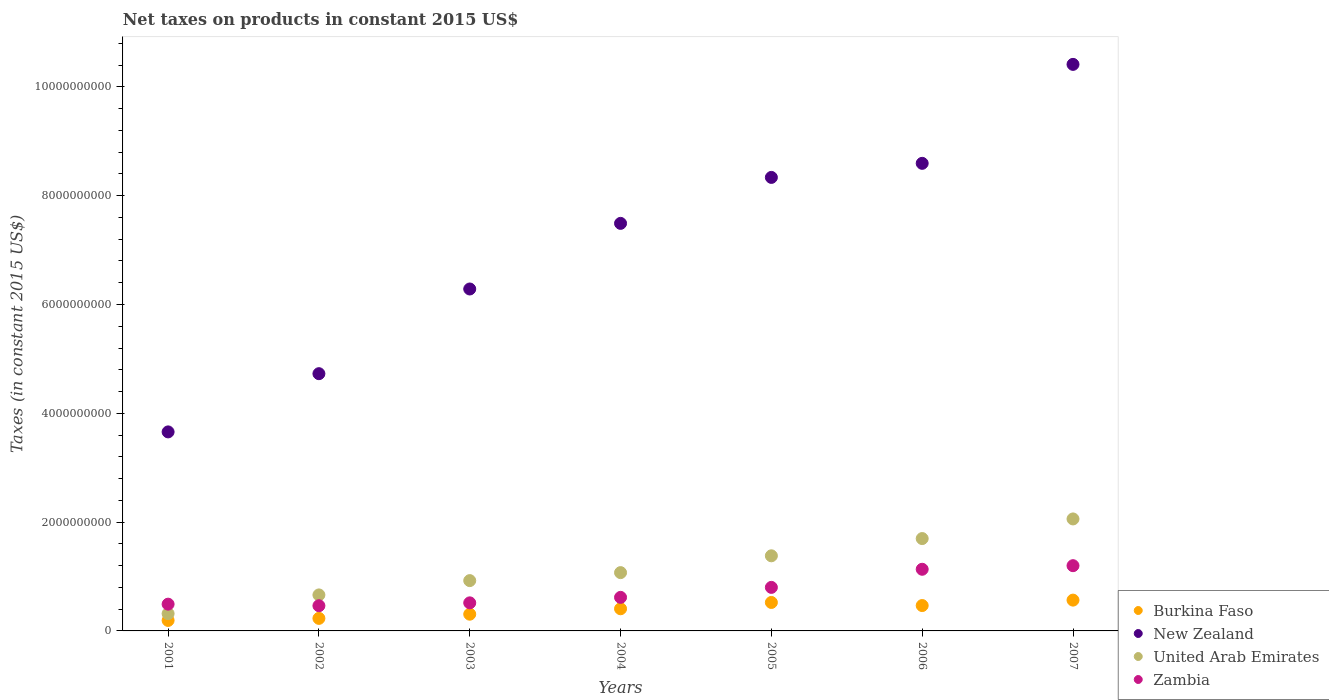What is the net taxes on products in New Zealand in 2002?
Keep it short and to the point. 4.73e+09. Across all years, what is the maximum net taxes on products in United Arab Emirates?
Provide a short and direct response. 2.06e+09. Across all years, what is the minimum net taxes on products in Zambia?
Your answer should be compact. 4.63e+08. What is the total net taxes on products in Burkina Faso in the graph?
Offer a very short reply. 2.69e+09. What is the difference between the net taxes on products in New Zealand in 2002 and that in 2006?
Give a very brief answer. -3.87e+09. What is the difference between the net taxes on products in New Zealand in 2006 and the net taxes on products in United Arab Emirates in 2004?
Provide a succinct answer. 7.52e+09. What is the average net taxes on products in United Arab Emirates per year?
Your answer should be compact. 1.16e+09. In the year 2005, what is the difference between the net taxes on products in Burkina Faso and net taxes on products in United Arab Emirates?
Offer a terse response. -8.57e+08. In how many years, is the net taxes on products in Zambia greater than 8800000000 US$?
Provide a short and direct response. 0. What is the ratio of the net taxes on products in Burkina Faso in 2006 to that in 2007?
Ensure brevity in your answer.  0.82. Is the net taxes on products in Zambia in 2005 less than that in 2006?
Your response must be concise. Yes. What is the difference between the highest and the second highest net taxes on products in United Arab Emirates?
Provide a succinct answer. 3.61e+08. What is the difference between the highest and the lowest net taxes on products in New Zealand?
Provide a succinct answer. 6.76e+09. In how many years, is the net taxes on products in Burkina Faso greater than the average net taxes on products in Burkina Faso taken over all years?
Ensure brevity in your answer.  4. Does the net taxes on products in Burkina Faso monotonically increase over the years?
Ensure brevity in your answer.  No. Is the net taxes on products in Burkina Faso strictly greater than the net taxes on products in Zambia over the years?
Offer a terse response. No. Is the net taxes on products in United Arab Emirates strictly less than the net taxes on products in Zambia over the years?
Give a very brief answer. No. How many years are there in the graph?
Keep it short and to the point. 7. Does the graph contain any zero values?
Provide a succinct answer. No. Does the graph contain grids?
Provide a short and direct response. No. How many legend labels are there?
Offer a very short reply. 4. What is the title of the graph?
Your answer should be compact. Net taxes on products in constant 2015 US$. What is the label or title of the Y-axis?
Keep it short and to the point. Taxes (in constant 2015 US$). What is the Taxes (in constant 2015 US$) in Burkina Faso in 2001?
Your response must be concise. 1.93e+08. What is the Taxes (in constant 2015 US$) of New Zealand in 2001?
Your answer should be very brief. 3.66e+09. What is the Taxes (in constant 2015 US$) in United Arab Emirates in 2001?
Provide a succinct answer. 3.18e+08. What is the Taxes (in constant 2015 US$) of Zambia in 2001?
Offer a terse response. 4.92e+08. What is the Taxes (in constant 2015 US$) in Burkina Faso in 2002?
Offer a very short reply. 2.31e+08. What is the Taxes (in constant 2015 US$) in New Zealand in 2002?
Provide a short and direct response. 4.73e+09. What is the Taxes (in constant 2015 US$) of United Arab Emirates in 2002?
Your answer should be compact. 6.62e+08. What is the Taxes (in constant 2015 US$) of Zambia in 2002?
Give a very brief answer. 4.63e+08. What is the Taxes (in constant 2015 US$) of Burkina Faso in 2003?
Your response must be concise. 3.07e+08. What is the Taxes (in constant 2015 US$) in New Zealand in 2003?
Offer a terse response. 6.28e+09. What is the Taxes (in constant 2015 US$) of United Arab Emirates in 2003?
Keep it short and to the point. 9.25e+08. What is the Taxes (in constant 2015 US$) of Zambia in 2003?
Your answer should be very brief. 5.16e+08. What is the Taxes (in constant 2015 US$) of Burkina Faso in 2004?
Keep it short and to the point. 4.07e+08. What is the Taxes (in constant 2015 US$) of New Zealand in 2004?
Offer a very short reply. 7.49e+09. What is the Taxes (in constant 2015 US$) in United Arab Emirates in 2004?
Provide a succinct answer. 1.07e+09. What is the Taxes (in constant 2015 US$) of Zambia in 2004?
Your response must be concise. 6.17e+08. What is the Taxes (in constant 2015 US$) of Burkina Faso in 2005?
Your answer should be compact. 5.23e+08. What is the Taxes (in constant 2015 US$) of New Zealand in 2005?
Keep it short and to the point. 8.34e+09. What is the Taxes (in constant 2015 US$) of United Arab Emirates in 2005?
Provide a short and direct response. 1.38e+09. What is the Taxes (in constant 2015 US$) of Zambia in 2005?
Ensure brevity in your answer.  8.00e+08. What is the Taxes (in constant 2015 US$) in Burkina Faso in 2006?
Your answer should be very brief. 4.66e+08. What is the Taxes (in constant 2015 US$) of New Zealand in 2006?
Keep it short and to the point. 8.59e+09. What is the Taxes (in constant 2015 US$) of United Arab Emirates in 2006?
Your answer should be compact. 1.70e+09. What is the Taxes (in constant 2015 US$) of Zambia in 2006?
Provide a short and direct response. 1.13e+09. What is the Taxes (in constant 2015 US$) of Burkina Faso in 2007?
Offer a terse response. 5.66e+08. What is the Taxes (in constant 2015 US$) in New Zealand in 2007?
Keep it short and to the point. 1.04e+1. What is the Taxes (in constant 2015 US$) of United Arab Emirates in 2007?
Offer a very short reply. 2.06e+09. What is the Taxes (in constant 2015 US$) in Zambia in 2007?
Your response must be concise. 1.20e+09. Across all years, what is the maximum Taxes (in constant 2015 US$) of Burkina Faso?
Offer a terse response. 5.66e+08. Across all years, what is the maximum Taxes (in constant 2015 US$) in New Zealand?
Give a very brief answer. 1.04e+1. Across all years, what is the maximum Taxes (in constant 2015 US$) in United Arab Emirates?
Your answer should be compact. 2.06e+09. Across all years, what is the maximum Taxes (in constant 2015 US$) in Zambia?
Give a very brief answer. 1.20e+09. Across all years, what is the minimum Taxes (in constant 2015 US$) in Burkina Faso?
Offer a very short reply. 1.93e+08. Across all years, what is the minimum Taxes (in constant 2015 US$) of New Zealand?
Offer a very short reply. 3.66e+09. Across all years, what is the minimum Taxes (in constant 2015 US$) of United Arab Emirates?
Ensure brevity in your answer.  3.18e+08. Across all years, what is the minimum Taxes (in constant 2015 US$) in Zambia?
Provide a succinct answer. 4.63e+08. What is the total Taxes (in constant 2015 US$) of Burkina Faso in the graph?
Ensure brevity in your answer.  2.69e+09. What is the total Taxes (in constant 2015 US$) of New Zealand in the graph?
Offer a terse response. 4.95e+1. What is the total Taxes (in constant 2015 US$) of United Arab Emirates in the graph?
Offer a very short reply. 8.11e+09. What is the total Taxes (in constant 2015 US$) of Zambia in the graph?
Make the answer very short. 5.22e+09. What is the difference between the Taxes (in constant 2015 US$) in Burkina Faso in 2001 and that in 2002?
Give a very brief answer. -3.78e+07. What is the difference between the Taxes (in constant 2015 US$) in New Zealand in 2001 and that in 2002?
Offer a very short reply. -1.07e+09. What is the difference between the Taxes (in constant 2015 US$) of United Arab Emirates in 2001 and that in 2002?
Your response must be concise. -3.44e+08. What is the difference between the Taxes (in constant 2015 US$) in Zambia in 2001 and that in 2002?
Your answer should be compact. 2.89e+07. What is the difference between the Taxes (in constant 2015 US$) of Burkina Faso in 2001 and that in 2003?
Your answer should be compact. -1.15e+08. What is the difference between the Taxes (in constant 2015 US$) in New Zealand in 2001 and that in 2003?
Your response must be concise. -2.63e+09. What is the difference between the Taxes (in constant 2015 US$) in United Arab Emirates in 2001 and that in 2003?
Make the answer very short. -6.07e+08. What is the difference between the Taxes (in constant 2015 US$) in Zambia in 2001 and that in 2003?
Give a very brief answer. -2.42e+07. What is the difference between the Taxes (in constant 2015 US$) in Burkina Faso in 2001 and that in 2004?
Make the answer very short. -2.14e+08. What is the difference between the Taxes (in constant 2015 US$) in New Zealand in 2001 and that in 2004?
Offer a terse response. -3.83e+09. What is the difference between the Taxes (in constant 2015 US$) in United Arab Emirates in 2001 and that in 2004?
Offer a very short reply. -7.54e+08. What is the difference between the Taxes (in constant 2015 US$) of Zambia in 2001 and that in 2004?
Make the answer very short. -1.25e+08. What is the difference between the Taxes (in constant 2015 US$) in Burkina Faso in 2001 and that in 2005?
Offer a terse response. -3.30e+08. What is the difference between the Taxes (in constant 2015 US$) of New Zealand in 2001 and that in 2005?
Provide a short and direct response. -4.68e+09. What is the difference between the Taxes (in constant 2015 US$) of United Arab Emirates in 2001 and that in 2005?
Keep it short and to the point. -1.06e+09. What is the difference between the Taxes (in constant 2015 US$) of Zambia in 2001 and that in 2005?
Provide a succinct answer. -3.08e+08. What is the difference between the Taxes (in constant 2015 US$) in Burkina Faso in 2001 and that in 2006?
Provide a short and direct response. -2.74e+08. What is the difference between the Taxes (in constant 2015 US$) in New Zealand in 2001 and that in 2006?
Your answer should be very brief. -4.94e+09. What is the difference between the Taxes (in constant 2015 US$) of United Arab Emirates in 2001 and that in 2006?
Ensure brevity in your answer.  -1.38e+09. What is the difference between the Taxes (in constant 2015 US$) in Zambia in 2001 and that in 2006?
Ensure brevity in your answer.  -6.41e+08. What is the difference between the Taxes (in constant 2015 US$) of Burkina Faso in 2001 and that in 2007?
Your answer should be very brief. -3.73e+08. What is the difference between the Taxes (in constant 2015 US$) of New Zealand in 2001 and that in 2007?
Provide a short and direct response. -6.76e+09. What is the difference between the Taxes (in constant 2015 US$) in United Arab Emirates in 2001 and that in 2007?
Keep it short and to the point. -1.74e+09. What is the difference between the Taxes (in constant 2015 US$) in Zambia in 2001 and that in 2007?
Provide a short and direct response. -7.07e+08. What is the difference between the Taxes (in constant 2015 US$) of Burkina Faso in 2002 and that in 2003?
Give a very brief answer. -7.69e+07. What is the difference between the Taxes (in constant 2015 US$) of New Zealand in 2002 and that in 2003?
Your response must be concise. -1.56e+09. What is the difference between the Taxes (in constant 2015 US$) in United Arab Emirates in 2002 and that in 2003?
Give a very brief answer. -2.63e+08. What is the difference between the Taxes (in constant 2015 US$) in Zambia in 2002 and that in 2003?
Offer a terse response. -5.31e+07. What is the difference between the Taxes (in constant 2015 US$) of Burkina Faso in 2002 and that in 2004?
Keep it short and to the point. -1.77e+08. What is the difference between the Taxes (in constant 2015 US$) of New Zealand in 2002 and that in 2004?
Provide a short and direct response. -2.76e+09. What is the difference between the Taxes (in constant 2015 US$) of United Arab Emirates in 2002 and that in 2004?
Offer a very short reply. -4.10e+08. What is the difference between the Taxes (in constant 2015 US$) of Zambia in 2002 and that in 2004?
Your response must be concise. -1.54e+08. What is the difference between the Taxes (in constant 2015 US$) in Burkina Faso in 2002 and that in 2005?
Give a very brief answer. -2.93e+08. What is the difference between the Taxes (in constant 2015 US$) of New Zealand in 2002 and that in 2005?
Your answer should be compact. -3.61e+09. What is the difference between the Taxes (in constant 2015 US$) of United Arab Emirates in 2002 and that in 2005?
Your response must be concise. -7.19e+08. What is the difference between the Taxes (in constant 2015 US$) of Zambia in 2002 and that in 2005?
Keep it short and to the point. -3.37e+08. What is the difference between the Taxes (in constant 2015 US$) in Burkina Faso in 2002 and that in 2006?
Keep it short and to the point. -2.36e+08. What is the difference between the Taxes (in constant 2015 US$) in New Zealand in 2002 and that in 2006?
Your answer should be very brief. -3.87e+09. What is the difference between the Taxes (in constant 2015 US$) in United Arab Emirates in 2002 and that in 2006?
Keep it short and to the point. -1.04e+09. What is the difference between the Taxes (in constant 2015 US$) in Zambia in 2002 and that in 2006?
Ensure brevity in your answer.  -6.70e+08. What is the difference between the Taxes (in constant 2015 US$) of Burkina Faso in 2002 and that in 2007?
Your response must be concise. -3.36e+08. What is the difference between the Taxes (in constant 2015 US$) in New Zealand in 2002 and that in 2007?
Offer a very short reply. -5.68e+09. What is the difference between the Taxes (in constant 2015 US$) of United Arab Emirates in 2002 and that in 2007?
Make the answer very short. -1.40e+09. What is the difference between the Taxes (in constant 2015 US$) in Zambia in 2002 and that in 2007?
Provide a succinct answer. -7.36e+08. What is the difference between the Taxes (in constant 2015 US$) of Burkina Faso in 2003 and that in 2004?
Offer a terse response. -9.97e+07. What is the difference between the Taxes (in constant 2015 US$) of New Zealand in 2003 and that in 2004?
Give a very brief answer. -1.21e+09. What is the difference between the Taxes (in constant 2015 US$) in United Arab Emirates in 2003 and that in 2004?
Your response must be concise. -1.47e+08. What is the difference between the Taxes (in constant 2015 US$) in Zambia in 2003 and that in 2004?
Keep it short and to the point. -1.01e+08. What is the difference between the Taxes (in constant 2015 US$) in Burkina Faso in 2003 and that in 2005?
Make the answer very short. -2.16e+08. What is the difference between the Taxes (in constant 2015 US$) in New Zealand in 2003 and that in 2005?
Offer a terse response. -2.05e+09. What is the difference between the Taxes (in constant 2015 US$) of United Arab Emirates in 2003 and that in 2005?
Your response must be concise. -4.56e+08. What is the difference between the Taxes (in constant 2015 US$) in Zambia in 2003 and that in 2005?
Your answer should be very brief. -2.84e+08. What is the difference between the Taxes (in constant 2015 US$) of Burkina Faso in 2003 and that in 2006?
Offer a very short reply. -1.59e+08. What is the difference between the Taxes (in constant 2015 US$) in New Zealand in 2003 and that in 2006?
Give a very brief answer. -2.31e+09. What is the difference between the Taxes (in constant 2015 US$) in United Arab Emirates in 2003 and that in 2006?
Offer a terse response. -7.73e+08. What is the difference between the Taxes (in constant 2015 US$) in Zambia in 2003 and that in 2006?
Provide a short and direct response. -6.17e+08. What is the difference between the Taxes (in constant 2015 US$) of Burkina Faso in 2003 and that in 2007?
Offer a very short reply. -2.59e+08. What is the difference between the Taxes (in constant 2015 US$) of New Zealand in 2003 and that in 2007?
Make the answer very short. -4.13e+09. What is the difference between the Taxes (in constant 2015 US$) of United Arab Emirates in 2003 and that in 2007?
Offer a very short reply. -1.13e+09. What is the difference between the Taxes (in constant 2015 US$) of Zambia in 2003 and that in 2007?
Make the answer very short. -6.83e+08. What is the difference between the Taxes (in constant 2015 US$) of Burkina Faso in 2004 and that in 2005?
Provide a short and direct response. -1.16e+08. What is the difference between the Taxes (in constant 2015 US$) in New Zealand in 2004 and that in 2005?
Offer a very short reply. -8.45e+08. What is the difference between the Taxes (in constant 2015 US$) of United Arab Emirates in 2004 and that in 2005?
Make the answer very short. -3.09e+08. What is the difference between the Taxes (in constant 2015 US$) of Zambia in 2004 and that in 2005?
Provide a short and direct response. -1.84e+08. What is the difference between the Taxes (in constant 2015 US$) of Burkina Faso in 2004 and that in 2006?
Offer a very short reply. -5.92e+07. What is the difference between the Taxes (in constant 2015 US$) of New Zealand in 2004 and that in 2006?
Your answer should be compact. -1.10e+09. What is the difference between the Taxes (in constant 2015 US$) in United Arab Emirates in 2004 and that in 2006?
Your answer should be compact. -6.26e+08. What is the difference between the Taxes (in constant 2015 US$) of Zambia in 2004 and that in 2006?
Offer a very short reply. -5.16e+08. What is the difference between the Taxes (in constant 2015 US$) in Burkina Faso in 2004 and that in 2007?
Offer a terse response. -1.59e+08. What is the difference between the Taxes (in constant 2015 US$) of New Zealand in 2004 and that in 2007?
Your response must be concise. -2.92e+09. What is the difference between the Taxes (in constant 2015 US$) in United Arab Emirates in 2004 and that in 2007?
Provide a short and direct response. -9.87e+08. What is the difference between the Taxes (in constant 2015 US$) of Zambia in 2004 and that in 2007?
Give a very brief answer. -5.82e+08. What is the difference between the Taxes (in constant 2015 US$) in Burkina Faso in 2005 and that in 2006?
Your answer should be compact. 5.68e+07. What is the difference between the Taxes (in constant 2015 US$) in New Zealand in 2005 and that in 2006?
Your answer should be very brief. -2.59e+08. What is the difference between the Taxes (in constant 2015 US$) of United Arab Emirates in 2005 and that in 2006?
Keep it short and to the point. -3.17e+08. What is the difference between the Taxes (in constant 2015 US$) in Zambia in 2005 and that in 2006?
Keep it short and to the point. -3.33e+08. What is the difference between the Taxes (in constant 2015 US$) of Burkina Faso in 2005 and that in 2007?
Provide a succinct answer. -4.30e+07. What is the difference between the Taxes (in constant 2015 US$) of New Zealand in 2005 and that in 2007?
Ensure brevity in your answer.  -2.08e+09. What is the difference between the Taxes (in constant 2015 US$) in United Arab Emirates in 2005 and that in 2007?
Make the answer very short. -6.78e+08. What is the difference between the Taxes (in constant 2015 US$) of Zambia in 2005 and that in 2007?
Make the answer very short. -3.99e+08. What is the difference between the Taxes (in constant 2015 US$) of Burkina Faso in 2006 and that in 2007?
Offer a very short reply. -9.98e+07. What is the difference between the Taxes (in constant 2015 US$) in New Zealand in 2006 and that in 2007?
Offer a very short reply. -1.82e+09. What is the difference between the Taxes (in constant 2015 US$) of United Arab Emirates in 2006 and that in 2007?
Give a very brief answer. -3.61e+08. What is the difference between the Taxes (in constant 2015 US$) in Zambia in 2006 and that in 2007?
Your answer should be compact. -6.60e+07. What is the difference between the Taxes (in constant 2015 US$) in Burkina Faso in 2001 and the Taxes (in constant 2015 US$) in New Zealand in 2002?
Offer a very short reply. -4.54e+09. What is the difference between the Taxes (in constant 2015 US$) of Burkina Faso in 2001 and the Taxes (in constant 2015 US$) of United Arab Emirates in 2002?
Provide a succinct answer. -4.69e+08. What is the difference between the Taxes (in constant 2015 US$) in Burkina Faso in 2001 and the Taxes (in constant 2015 US$) in Zambia in 2002?
Keep it short and to the point. -2.70e+08. What is the difference between the Taxes (in constant 2015 US$) in New Zealand in 2001 and the Taxes (in constant 2015 US$) in United Arab Emirates in 2002?
Your answer should be very brief. 3.00e+09. What is the difference between the Taxes (in constant 2015 US$) in New Zealand in 2001 and the Taxes (in constant 2015 US$) in Zambia in 2002?
Offer a very short reply. 3.20e+09. What is the difference between the Taxes (in constant 2015 US$) in United Arab Emirates in 2001 and the Taxes (in constant 2015 US$) in Zambia in 2002?
Offer a very short reply. -1.45e+08. What is the difference between the Taxes (in constant 2015 US$) in Burkina Faso in 2001 and the Taxes (in constant 2015 US$) in New Zealand in 2003?
Make the answer very short. -6.09e+09. What is the difference between the Taxes (in constant 2015 US$) of Burkina Faso in 2001 and the Taxes (in constant 2015 US$) of United Arab Emirates in 2003?
Make the answer very short. -7.32e+08. What is the difference between the Taxes (in constant 2015 US$) in Burkina Faso in 2001 and the Taxes (in constant 2015 US$) in Zambia in 2003?
Make the answer very short. -3.23e+08. What is the difference between the Taxes (in constant 2015 US$) of New Zealand in 2001 and the Taxes (in constant 2015 US$) of United Arab Emirates in 2003?
Your response must be concise. 2.73e+09. What is the difference between the Taxes (in constant 2015 US$) of New Zealand in 2001 and the Taxes (in constant 2015 US$) of Zambia in 2003?
Ensure brevity in your answer.  3.14e+09. What is the difference between the Taxes (in constant 2015 US$) in United Arab Emirates in 2001 and the Taxes (in constant 2015 US$) in Zambia in 2003?
Keep it short and to the point. -1.98e+08. What is the difference between the Taxes (in constant 2015 US$) of Burkina Faso in 2001 and the Taxes (in constant 2015 US$) of New Zealand in 2004?
Make the answer very short. -7.30e+09. What is the difference between the Taxes (in constant 2015 US$) of Burkina Faso in 2001 and the Taxes (in constant 2015 US$) of United Arab Emirates in 2004?
Offer a very short reply. -8.79e+08. What is the difference between the Taxes (in constant 2015 US$) of Burkina Faso in 2001 and the Taxes (in constant 2015 US$) of Zambia in 2004?
Make the answer very short. -4.24e+08. What is the difference between the Taxes (in constant 2015 US$) of New Zealand in 2001 and the Taxes (in constant 2015 US$) of United Arab Emirates in 2004?
Your answer should be compact. 2.59e+09. What is the difference between the Taxes (in constant 2015 US$) of New Zealand in 2001 and the Taxes (in constant 2015 US$) of Zambia in 2004?
Ensure brevity in your answer.  3.04e+09. What is the difference between the Taxes (in constant 2015 US$) of United Arab Emirates in 2001 and the Taxes (in constant 2015 US$) of Zambia in 2004?
Your answer should be very brief. -2.99e+08. What is the difference between the Taxes (in constant 2015 US$) of Burkina Faso in 2001 and the Taxes (in constant 2015 US$) of New Zealand in 2005?
Make the answer very short. -8.14e+09. What is the difference between the Taxes (in constant 2015 US$) in Burkina Faso in 2001 and the Taxes (in constant 2015 US$) in United Arab Emirates in 2005?
Your answer should be compact. -1.19e+09. What is the difference between the Taxes (in constant 2015 US$) in Burkina Faso in 2001 and the Taxes (in constant 2015 US$) in Zambia in 2005?
Provide a succinct answer. -6.07e+08. What is the difference between the Taxes (in constant 2015 US$) in New Zealand in 2001 and the Taxes (in constant 2015 US$) in United Arab Emirates in 2005?
Keep it short and to the point. 2.28e+09. What is the difference between the Taxes (in constant 2015 US$) in New Zealand in 2001 and the Taxes (in constant 2015 US$) in Zambia in 2005?
Provide a succinct answer. 2.86e+09. What is the difference between the Taxes (in constant 2015 US$) of United Arab Emirates in 2001 and the Taxes (in constant 2015 US$) of Zambia in 2005?
Give a very brief answer. -4.82e+08. What is the difference between the Taxes (in constant 2015 US$) of Burkina Faso in 2001 and the Taxes (in constant 2015 US$) of New Zealand in 2006?
Give a very brief answer. -8.40e+09. What is the difference between the Taxes (in constant 2015 US$) in Burkina Faso in 2001 and the Taxes (in constant 2015 US$) in United Arab Emirates in 2006?
Ensure brevity in your answer.  -1.50e+09. What is the difference between the Taxes (in constant 2015 US$) in Burkina Faso in 2001 and the Taxes (in constant 2015 US$) in Zambia in 2006?
Provide a short and direct response. -9.40e+08. What is the difference between the Taxes (in constant 2015 US$) in New Zealand in 2001 and the Taxes (in constant 2015 US$) in United Arab Emirates in 2006?
Ensure brevity in your answer.  1.96e+09. What is the difference between the Taxes (in constant 2015 US$) in New Zealand in 2001 and the Taxes (in constant 2015 US$) in Zambia in 2006?
Provide a succinct answer. 2.52e+09. What is the difference between the Taxes (in constant 2015 US$) of United Arab Emirates in 2001 and the Taxes (in constant 2015 US$) of Zambia in 2006?
Offer a terse response. -8.15e+08. What is the difference between the Taxes (in constant 2015 US$) of Burkina Faso in 2001 and the Taxes (in constant 2015 US$) of New Zealand in 2007?
Provide a succinct answer. -1.02e+1. What is the difference between the Taxes (in constant 2015 US$) of Burkina Faso in 2001 and the Taxes (in constant 2015 US$) of United Arab Emirates in 2007?
Ensure brevity in your answer.  -1.87e+09. What is the difference between the Taxes (in constant 2015 US$) in Burkina Faso in 2001 and the Taxes (in constant 2015 US$) in Zambia in 2007?
Ensure brevity in your answer.  -1.01e+09. What is the difference between the Taxes (in constant 2015 US$) in New Zealand in 2001 and the Taxes (in constant 2015 US$) in United Arab Emirates in 2007?
Make the answer very short. 1.60e+09. What is the difference between the Taxes (in constant 2015 US$) of New Zealand in 2001 and the Taxes (in constant 2015 US$) of Zambia in 2007?
Provide a short and direct response. 2.46e+09. What is the difference between the Taxes (in constant 2015 US$) in United Arab Emirates in 2001 and the Taxes (in constant 2015 US$) in Zambia in 2007?
Ensure brevity in your answer.  -8.81e+08. What is the difference between the Taxes (in constant 2015 US$) of Burkina Faso in 2002 and the Taxes (in constant 2015 US$) of New Zealand in 2003?
Provide a short and direct response. -6.05e+09. What is the difference between the Taxes (in constant 2015 US$) in Burkina Faso in 2002 and the Taxes (in constant 2015 US$) in United Arab Emirates in 2003?
Give a very brief answer. -6.94e+08. What is the difference between the Taxes (in constant 2015 US$) in Burkina Faso in 2002 and the Taxes (in constant 2015 US$) in Zambia in 2003?
Your answer should be very brief. -2.86e+08. What is the difference between the Taxes (in constant 2015 US$) in New Zealand in 2002 and the Taxes (in constant 2015 US$) in United Arab Emirates in 2003?
Offer a terse response. 3.80e+09. What is the difference between the Taxes (in constant 2015 US$) in New Zealand in 2002 and the Taxes (in constant 2015 US$) in Zambia in 2003?
Provide a short and direct response. 4.21e+09. What is the difference between the Taxes (in constant 2015 US$) in United Arab Emirates in 2002 and the Taxes (in constant 2015 US$) in Zambia in 2003?
Your answer should be compact. 1.46e+08. What is the difference between the Taxes (in constant 2015 US$) of Burkina Faso in 2002 and the Taxes (in constant 2015 US$) of New Zealand in 2004?
Make the answer very short. -7.26e+09. What is the difference between the Taxes (in constant 2015 US$) of Burkina Faso in 2002 and the Taxes (in constant 2015 US$) of United Arab Emirates in 2004?
Provide a short and direct response. -8.41e+08. What is the difference between the Taxes (in constant 2015 US$) in Burkina Faso in 2002 and the Taxes (in constant 2015 US$) in Zambia in 2004?
Your answer should be very brief. -3.86e+08. What is the difference between the Taxes (in constant 2015 US$) in New Zealand in 2002 and the Taxes (in constant 2015 US$) in United Arab Emirates in 2004?
Your answer should be compact. 3.66e+09. What is the difference between the Taxes (in constant 2015 US$) in New Zealand in 2002 and the Taxes (in constant 2015 US$) in Zambia in 2004?
Your answer should be compact. 4.11e+09. What is the difference between the Taxes (in constant 2015 US$) in United Arab Emirates in 2002 and the Taxes (in constant 2015 US$) in Zambia in 2004?
Offer a very short reply. 4.50e+07. What is the difference between the Taxes (in constant 2015 US$) of Burkina Faso in 2002 and the Taxes (in constant 2015 US$) of New Zealand in 2005?
Your answer should be compact. -8.11e+09. What is the difference between the Taxes (in constant 2015 US$) in Burkina Faso in 2002 and the Taxes (in constant 2015 US$) in United Arab Emirates in 2005?
Your response must be concise. -1.15e+09. What is the difference between the Taxes (in constant 2015 US$) of Burkina Faso in 2002 and the Taxes (in constant 2015 US$) of Zambia in 2005?
Offer a very short reply. -5.70e+08. What is the difference between the Taxes (in constant 2015 US$) in New Zealand in 2002 and the Taxes (in constant 2015 US$) in United Arab Emirates in 2005?
Provide a succinct answer. 3.35e+09. What is the difference between the Taxes (in constant 2015 US$) of New Zealand in 2002 and the Taxes (in constant 2015 US$) of Zambia in 2005?
Your response must be concise. 3.93e+09. What is the difference between the Taxes (in constant 2015 US$) of United Arab Emirates in 2002 and the Taxes (in constant 2015 US$) of Zambia in 2005?
Make the answer very short. -1.39e+08. What is the difference between the Taxes (in constant 2015 US$) in Burkina Faso in 2002 and the Taxes (in constant 2015 US$) in New Zealand in 2006?
Your response must be concise. -8.36e+09. What is the difference between the Taxes (in constant 2015 US$) of Burkina Faso in 2002 and the Taxes (in constant 2015 US$) of United Arab Emirates in 2006?
Your response must be concise. -1.47e+09. What is the difference between the Taxes (in constant 2015 US$) of Burkina Faso in 2002 and the Taxes (in constant 2015 US$) of Zambia in 2006?
Offer a very short reply. -9.03e+08. What is the difference between the Taxes (in constant 2015 US$) in New Zealand in 2002 and the Taxes (in constant 2015 US$) in United Arab Emirates in 2006?
Give a very brief answer. 3.03e+09. What is the difference between the Taxes (in constant 2015 US$) of New Zealand in 2002 and the Taxes (in constant 2015 US$) of Zambia in 2006?
Keep it short and to the point. 3.59e+09. What is the difference between the Taxes (in constant 2015 US$) of United Arab Emirates in 2002 and the Taxes (in constant 2015 US$) of Zambia in 2006?
Your response must be concise. -4.71e+08. What is the difference between the Taxes (in constant 2015 US$) in Burkina Faso in 2002 and the Taxes (in constant 2015 US$) in New Zealand in 2007?
Make the answer very short. -1.02e+1. What is the difference between the Taxes (in constant 2015 US$) in Burkina Faso in 2002 and the Taxes (in constant 2015 US$) in United Arab Emirates in 2007?
Provide a succinct answer. -1.83e+09. What is the difference between the Taxes (in constant 2015 US$) in Burkina Faso in 2002 and the Taxes (in constant 2015 US$) in Zambia in 2007?
Ensure brevity in your answer.  -9.69e+08. What is the difference between the Taxes (in constant 2015 US$) in New Zealand in 2002 and the Taxes (in constant 2015 US$) in United Arab Emirates in 2007?
Your answer should be very brief. 2.67e+09. What is the difference between the Taxes (in constant 2015 US$) in New Zealand in 2002 and the Taxes (in constant 2015 US$) in Zambia in 2007?
Your response must be concise. 3.53e+09. What is the difference between the Taxes (in constant 2015 US$) of United Arab Emirates in 2002 and the Taxes (in constant 2015 US$) of Zambia in 2007?
Offer a terse response. -5.37e+08. What is the difference between the Taxes (in constant 2015 US$) in Burkina Faso in 2003 and the Taxes (in constant 2015 US$) in New Zealand in 2004?
Your answer should be compact. -7.18e+09. What is the difference between the Taxes (in constant 2015 US$) of Burkina Faso in 2003 and the Taxes (in constant 2015 US$) of United Arab Emirates in 2004?
Offer a terse response. -7.64e+08. What is the difference between the Taxes (in constant 2015 US$) of Burkina Faso in 2003 and the Taxes (in constant 2015 US$) of Zambia in 2004?
Make the answer very short. -3.09e+08. What is the difference between the Taxes (in constant 2015 US$) in New Zealand in 2003 and the Taxes (in constant 2015 US$) in United Arab Emirates in 2004?
Make the answer very short. 5.21e+09. What is the difference between the Taxes (in constant 2015 US$) in New Zealand in 2003 and the Taxes (in constant 2015 US$) in Zambia in 2004?
Keep it short and to the point. 5.67e+09. What is the difference between the Taxes (in constant 2015 US$) in United Arab Emirates in 2003 and the Taxes (in constant 2015 US$) in Zambia in 2004?
Give a very brief answer. 3.08e+08. What is the difference between the Taxes (in constant 2015 US$) of Burkina Faso in 2003 and the Taxes (in constant 2015 US$) of New Zealand in 2005?
Your answer should be very brief. -8.03e+09. What is the difference between the Taxes (in constant 2015 US$) in Burkina Faso in 2003 and the Taxes (in constant 2015 US$) in United Arab Emirates in 2005?
Your answer should be very brief. -1.07e+09. What is the difference between the Taxes (in constant 2015 US$) in Burkina Faso in 2003 and the Taxes (in constant 2015 US$) in Zambia in 2005?
Provide a short and direct response. -4.93e+08. What is the difference between the Taxes (in constant 2015 US$) of New Zealand in 2003 and the Taxes (in constant 2015 US$) of United Arab Emirates in 2005?
Your response must be concise. 4.90e+09. What is the difference between the Taxes (in constant 2015 US$) of New Zealand in 2003 and the Taxes (in constant 2015 US$) of Zambia in 2005?
Your answer should be compact. 5.48e+09. What is the difference between the Taxes (in constant 2015 US$) of United Arab Emirates in 2003 and the Taxes (in constant 2015 US$) of Zambia in 2005?
Keep it short and to the point. 1.25e+08. What is the difference between the Taxes (in constant 2015 US$) in Burkina Faso in 2003 and the Taxes (in constant 2015 US$) in New Zealand in 2006?
Your answer should be compact. -8.29e+09. What is the difference between the Taxes (in constant 2015 US$) of Burkina Faso in 2003 and the Taxes (in constant 2015 US$) of United Arab Emirates in 2006?
Ensure brevity in your answer.  -1.39e+09. What is the difference between the Taxes (in constant 2015 US$) in Burkina Faso in 2003 and the Taxes (in constant 2015 US$) in Zambia in 2006?
Ensure brevity in your answer.  -8.26e+08. What is the difference between the Taxes (in constant 2015 US$) in New Zealand in 2003 and the Taxes (in constant 2015 US$) in United Arab Emirates in 2006?
Provide a succinct answer. 4.59e+09. What is the difference between the Taxes (in constant 2015 US$) in New Zealand in 2003 and the Taxes (in constant 2015 US$) in Zambia in 2006?
Your response must be concise. 5.15e+09. What is the difference between the Taxes (in constant 2015 US$) in United Arab Emirates in 2003 and the Taxes (in constant 2015 US$) in Zambia in 2006?
Your response must be concise. -2.08e+08. What is the difference between the Taxes (in constant 2015 US$) of Burkina Faso in 2003 and the Taxes (in constant 2015 US$) of New Zealand in 2007?
Your answer should be compact. -1.01e+1. What is the difference between the Taxes (in constant 2015 US$) of Burkina Faso in 2003 and the Taxes (in constant 2015 US$) of United Arab Emirates in 2007?
Provide a succinct answer. -1.75e+09. What is the difference between the Taxes (in constant 2015 US$) in Burkina Faso in 2003 and the Taxes (in constant 2015 US$) in Zambia in 2007?
Keep it short and to the point. -8.92e+08. What is the difference between the Taxes (in constant 2015 US$) in New Zealand in 2003 and the Taxes (in constant 2015 US$) in United Arab Emirates in 2007?
Provide a short and direct response. 4.23e+09. What is the difference between the Taxes (in constant 2015 US$) of New Zealand in 2003 and the Taxes (in constant 2015 US$) of Zambia in 2007?
Your answer should be very brief. 5.09e+09. What is the difference between the Taxes (in constant 2015 US$) of United Arab Emirates in 2003 and the Taxes (in constant 2015 US$) of Zambia in 2007?
Provide a short and direct response. -2.74e+08. What is the difference between the Taxes (in constant 2015 US$) in Burkina Faso in 2004 and the Taxes (in constant 2015 US$) in New Zealand in 2005?
Give a very brief answer. -7.93e+09. What is the difference between the Taxes (in constant 2015 US$) in Burkina Faso in 2004 and the Taxes (in constant 2015 US$) in United Arab Emirates in 2005?
Provide a short and direct response. -9.73e+08. What is the difference between the Taxes (in constant 2015 US$) of Burkina Faso in 2004 and the Taxes (in constant 2015 US$) of Zambia in 2005?
Your answer should be compact. -3.93e+08. What is the difference between the Taxes (in constant 2015 US$) in New Zealand in 2004 and the Taxes (in constant 2015 US$) in United Arab Emirates in 2005?
Provide a succinct answer. 6.11e+09. What is the difference between the Taxes (in constant 2015 US$) of New Zealand in 2004 and the Taxes (in constant 2015 US$) of Zambia in 2005?
Ensure brevity in your answer.  6.69e+09. What is the difference between the Taxes (in constant 2015 US$) of United Arab Emirates in 2004 and the Taxes (in constant 2015 US$) of Zambia in 2005?
Provide a succinct answer. 2.71e+08. What is the difference between the Taxes (in constant 2015 US$) of Burkina Faso in 2004 and the Taxes (in constant 2015 US$) of New Zealand in 2006?
Your answer should be very brief. -8.19e+09. What is the difference between the Taxes (in constant 2015 US$) in Burkina Faso in 2004 and the Taxes (in constant 2015 US$) in United Arab Emirates in 2006?
Give a very brief answer. -1.29e+09. What is the difference between the Taxes (in constant 2015 US$) of Burkina Faso in 2004 and the Taxes (in constant 2015 US$) of Zambia in 2006?
Provide a succinct answer. -7.26e+08. What is the difference between the Taxes (in constant 2015 US$) of New Zealand in 2004 and the Taxes (in constant 2015 US$) of United Arab Emirates in 2006?
Your answer should be very brief. 5.79e+09. What is the difference between the Taxes (in constant 2015 US$) of New Zealand in 2004 and the Taxes (in constant 2015 US$) of Zambia in 2006?
Provide a short and direct response. 6.36e+09. What is the difference between the Taxes (in constant 2015 US$) of United Arab Emirates in 2004 and the Taxes (in constant 2015 US$) of Zambia in 2006?
Offer a very short reply. -6.16e+07. What is the difference between the Taxes (in constant 2015 US$) in Burkina Faso in 2004 and the Taxes (in constant 2015 US$) in New Zealand in 2007?
Offer a very short reply. -1.00e+1. What is the difference between the Taxes (in constant 2015 US$) in Burkina Faso in 2004 and the Taxes (in constant 2015 US$) in United Arab Emirates in 2007?
Your response must be concise. -1.65e+09. What is the difference between the Taxes (in constant 2015 US$) in Burkina Faso in 2004 and the Taxes (in constant 2015 US$) in Zambia in 2007?
Your answer should be very brief. -7.92e+08. What is the difference between the Taxes (in constant 2015 US$) in New Zealand in 2004 and the Taxes (in constant 2015 US$) in United Arab Emirates in 2007?
Your answer should be compact. 5.43e+09. What is the difference between the Taxes (in constant 2015 US$) of New Zealand in 2004 and the Taxes (in constant 2015 US$) of Zambia in 2007?
Make the answer very short. 6.29e+09. What is the difference between the Taxes (in constant 2015 US$) of United Arab Emirates in 2004 and the Taxes (in constant 2015 US$) of Zambia in 2007?
Make the answer very short. -1.28e+08. What is the difference between the Taxes (in constant 2015 US$) of Burkina Faso in 2005 and the Taxes (in constant 2015 US$) of New Zealand in 2006?
Provide a succinct answer. -8.07e+09. What is the difference between the Taxes (in constant 2015 US$) in Burkina Faso in 2005 and the Taxes (in constant 2015 US$) in United Arab Emirates in 2006?
Your answer should be very brief. -1.17e+09. What is the difference between the Taxes (in constant 2015 US$) in Burkina Faso in 2005 and the Taxes (in constant 2015 US$) in Zambia in 2006?
Offer a terse response. -6.10e+08. What is the difference between the Taxes (in constant 2015 US$) of New Zealand in 2005 and the Taxes (in constant 2015 US$) of United Arab Emirates in 2006?
Offer a very short reply. 6.64e+09. What is the difference between the Taxes (in constant 2015 US$) of New Zealand in 2005 and the Taxes (in constant 2015 US$) of Zambia in 2006?
Provide a succinct answer. 7.20e+09. What is the difference between the Taxes (in constant 2015 US$) of United Arab Emirates in 2005 and the Taxes (in constant 2015 US$) of Zambia in 2006?
Give a very brief answer. 2.47e+08. What is the difference between the Taxes (in constant 2015 US$) of Burkina Faso in 2005 and the Taxes (in constant 2015 US$) of New Zealand in 2007?
Your answer should be very brief. -9.89e+09. What is the difference between the Taxes (in constant 2015 US$) in Burkina Faso in 2005 and the Taxes (in constant 2015 US$) in United Arab Emirates in 2007?
Give a very brief answer. -1.54e+09. What is the difference between the Taxes (in constant 2015 US$) in Burkina Faso in 2005 and the Taxes (in constant 2015 US$) in Zambia in 2007?
Ensure brevity in your answer.  -6.76e+08. What is the difference between the Taxes (in constant 2015 US$) in New Zealand in 2005 and the Taxes (in constant 2015 US$) in United Arab Emirates in 2007?
Your answer should be very brief. 6.28e+09. What is the difference between the Taxes (in constant 2015 US$) of New Zealand in 2005 and the Taxes (in constant 2015 US$) of Zambia in 2007?
Make the answer very short. 7.14e+09. What is the difference between the Taxes (in constant 2015 US$) in United Arab Emirates in 2005 and the Taxes (in constant 2015 US$) in Zambia in 2007?
Make the answer very short. 1.81e+08. What is the difference between the Taxes (in constant 2015 US$) of Burkina Faso in 2006 and the Taxes (in constant 2015 US$) of New Zealand in 2007?
Your answer should be very brief. -9.95e+09. What is the difference between the Taxes (in constant 2015 US$) in Burkina Faso in 2006 and the Taxes (in constant 2015 US$) in United Arab Emirates in 2007?
Offer a very short reply. -1.59e+09. What is the difference between the Taxes (in constant 2015 US$) in Burkina Faso in 2006 and the Taxes (in constant 2015 US$) in Zambia in 2007?
Offer a terse response. -7.33e+08. What is the difference between the Taxes (in constant 2015 US$) in New Zealand in 2006 and the Taxes (in constant 2015 US$) in United Arab Emirates in 2007?
Ensure brevity in your answer.  6.54e+09. What is the difference between the Taxes (in constant 2015 US$) in New Zealand in 2006 and the Taxes (in constant 2015 US$) in Zambia in 2007?
Your answer should be very brief. 7.39e+09. What is the difference between the Taxes (in constant 2015 US$) in United Arab Emirates in 2006 and the Taxes (in constant 2015 US$) in Zambia in 2007?
Provide a succinct answer. 4.98e+08. What is the average Taxes (in constant 2015 US$) of Burkina Faso per year?
Give a very brief answer. 3.85e+08. What is the average Taxes (in constant 2015 US$) in New Zealand per year?
Offer a terse response. 7.07e+09. What is the average Taxes (in constant 2015 US$) in United Arab Emirates per year?
Keep it short and to the point. 1.16e+09. What is the average Taxes (in constant 2015 US$) of Zambia per year?
Provide a succinct answer. 7.46e+08. In the year 2001, what is the difference between the Taxes (in constant 2015 US$) of Burkina Faso and Taxes (in constant 2015 US$) of New Zealand?
Provide a short and direct response. -3.47e+09. In the year 2001, what is the difference between the Taxes (in constant 2015 US$) in Burkina Faso and Taxes (in constant 2015 US$) in United Arab Emirates?
Offer a terse response. -1.25e+08. In the year 2001, what is the difference between the Taxes (in constant 2015 US$) of Burkina Faso and Taxes (in constant 2015 US$) of Zambia?
Keep it short and to the point. -2.99e+08. In the year 2001, what is the difference between the Taxes (in constant 2015 US$) in New Zealand and Taxes (in constant 2015 US$) in United Arab Emirates?
Make the answer very short. 3.34e+09. In the year 2001, what is the difference between the Taxes (in constant 2015 US$) of New Zealand and Taxes (in constant 2015 US$) of Zambia?
Make the answer very short. 3.17e+09. In the year 2001, what is the difference between the Taxes (in constant 2015 US$) in United Arab Emirates and Taxes (in constant 2015 US$) in Zambia?
Ensure brevity in your answer.  -1.74e+08. In the year 2002, what is the difference between the Taxes (in constant 2015 US$) in Burkina Faso and Taxes (in constant 2015 US$) in New Zealand?
Make the answer very short. -4.50e+09. In the year 2002, what is the difference between the Taxes (in constant 2015 US$) in Burkina Faso and Taxes (in constant 2015 US$) in United Arab Emirates?
Keep it short and to the point. -4.31e+08. In the year 2002, what is the difference between the Taxes (in constant 2015 US$) in Burkina Faso and Taxes (in constant 2015 US$) in Zambia?
Make the answer very short. -2.32e+08. In the year 2002, what is the difference between the Taxes (in constant 2015 US$) of New Zealand and Taxes (in constant 2015 US$) of United Arab Emirates?
Provide a short and direct response. 4.07e+09. In the year 2002, what is the difference between the Taxes (in constant 2015 US$) of New Zealand and Taxes (in constant 2015 US$) of Zambia?
Your answer should be compact. 4.27e+09. In the year 2002, what is the difference between the Taxes (in constant 2015 US$) in United Arab Emirates and Taxes (in constant 2015 US$) in Zambia?
Provide a short and direct response. 1.99e+08. In the year 2003, what is the difference between the Taxes (in constant 2015 US$) of Burkina Faso and Taxes (in constant 2015 US$) of New Zealand?
Give a very brief answer. -5.98e+09. In the year 2003, what is the difference between the Taxes (in constant 2015 US$) in Burkina Faso and Taxes (in constant 2015 US$) in United Arab Emirates?
Ensure brevity in your answer.  -6.17e+08. In the year 2003, what is the difference between the Taxes (in constant 2015 US$) of Burkina Faso and Taxes (in constant 2015 US$) of Zambia?
Your answer should be compact. -2.09e+08. In the year 2003, what is the difference between the Taxes (in constant 2015 US$) in New Zealand and Taxes (in constant 2015 US$) in United Arab Emirates?
Your answer should be compact. 5.36e+09. In the year 2003, what is the difference between the Taxes (in constant 2015 US$) of New Zealand and Taxes (in constant 2015 US$) of Zambia?
Offer a very short reply. 5.77e+09. In the year 2003, what is the difference between the Taxes (in constant 2015 US$) of United Arab Emirates and Taxes (in constant 2015 US$) of Zambia?
Give a very brief answer. 4.09e+08. In the year 2004, what is the difference between the Taxes (in constant 2015 US$) of Burkina Faso and Taxes (in constant 2015 US$) of New Zealand?
Your answer should be very brief. -7.08e+09. In the year 2004, what is the difference between the Taxes (in constant 2015 US$) of Burkina Faso and Taxes (in constant 2015 US$) of United Arab Emirates?
Keep it short and to the point. -6.64e+08. In the year 2004, what is the difference between the Taxes (in constant 2015 US$) in Burkina Faso and Taxes (in constant 2015 US$) in Zambia?
Provide a succinct answer. -2.10e+08. In the year 2004, what is the difference between the Taxes (in constant 2015 US$) in New Zealand and Taxes (in constant 2015 US$) in United Arab Emirates?
Your answer should be very brief. 6.42e+09. In the year 2004, what is the difference between the Taxes (in constant 2015 US$) in New Zealand and Taxes (in constant 2015 US$) in Zambia?
Your answer should be very brief. 6.87e+09. In the year 2004, what is the difference between the Taxes (in constant 2015 US$) in United Arab Emirates and Taxes (in constant 2015 US$) in Zambia?
Provide a succinct answer. 4.55e+08. In the year 2005, what is the difference between the Taxes (in constant 2015 US$) in Burkina Faso and Taxes (in constant 2015 US$) in New Zealand?
Make the answer very short. -7.81e+09. In the year 2005, what is the difference between the Taxes (in constant 2015 US$) in Burkina Faso and Taxes (in constant 2015 US$) in United Arab Emirates?
Your answer should be compact. -8.57e+08. In the year 2005, what is the difference between the Taxes (in constant 2015 US$) in Burkina Faso and Taxes (in constant 2015 US$) in Zambia?
Make the answer very short. -2.77e+08. In the year 2005, what is the difference between the Taxes (in constant 2015 US$) of New Zealand and Taxes (in constant 2015 US$) of United Arab Emirates?
Your response must be concise. 6.96e+09. In the year 2005, what is the difference between the Taxes (in constant 2015 US$) of New Zealand and Taxes (in constant 2015 US$) of Zambia?
Provide a short and direct response. 7.54e+09. In the year 2005, what is the difference between the Taxes (in constant 2015 US$) of United Arab Emirates and Taxes (in constant 2015 US$) of Zambia?
Keep it short and to the point. 5.80e+08. In the year 2006, what is the difference between the Taxes (in constant 2015 US$) in Burkina Faso and Taxes (in constant 2015 US$) in New Zealand?
Keep it short and to the point. -8.13e+09. In the year 2006, what is the difference between the Taxes (in constant 2015 US$) in Burkina Faso and Taxes (in constant 2015 US$) in United Arab Emirates?
Offer a very short reply. -1.23e+09. In the year 2006, what is the difference between the Taxes (in constant 2015 US$) in Burkina Faso and Taxes (in constant 2015 US$) in Zambia?
Your response must be concise. -6.67e+08. In the year 2006, what is the difference between the Taxes (in constant 2015 US$) of New Zealand and Taxes (in constant 2015 US$) of United Arab Emirates?
Ensure brevity in your answer.  6.90e+09. In the year 2006, what is the difference between the Taxes (in constant 2015 US$) of New Zealand and Taxes (in constant 2015 US$) of Zambia?
Offer a very short reply. 7.46e+09. In the year 2006, what is the difference between the Taxes (in constant 2015 US$) of United Arab Emirates and Taxes (in constant 2015 US$) of Zambia?
Provide a succinct answer. 5.64e+08. In the year 2007, what is the difference between the Taxes (in constant 2015 US$) of Burkina Faso and Taxes (in constant 2015 US$) of New Zealand?
Provide a short and direct response. -9.85e+09. In the year 2007, what is the difference between the Taxes (in constant 2015 US$) in Burkina Faso and Taxes (in constant 2015 US$) in United Arab Emirates?
Provide a succinct answer. -1.49e+09. In the year 2007, what is the difference between the Taxes (in constant 2015 US$) in Burkina Faso and Taxes (in constant 2015 US$) in Zambia?
Make the answer very short. -6.33e+08. In the year 2007, what is the difference between the Taxes (in constant 2015 US$) of New Zealand and Taxes (in constant 2015 US$) of United Arab Emirates?
Your answer should be very brief. 8.35e+09. In the year 2007, what is the difference between the Taxes (in constant 2015 US$) in New Zealand and Taxes (in constant 2015 US$) in Zambia?
Your answer should be compact. 9.21e+09. In the year 2007, what is the difference between the Taxes (in constant 2015 US$) of United Arab Emirates and Taxes (in constant 2015 US$) of Zambia?
Give a very brief answer. 8.59e+08. What is the ratio of the Taxes (in constant 2015 US$) of Burkina Faso in 2001 to that in 2002?
Give a very brief answer. 0.84. What is the ratio of the Taxes (in constant 2015 US$) of New Zealand in 2001 to that in 2002?
Ensure brevity in your answer.  0.77. What is the ratio of the Taxes (in constant 2015 US$) in United Arab Emirates in 2001 to that in 2002?
Keep it short and to the point. 0.48. What is the ratio of the Taxes (in constant 2015 US$) in Zambia in 2001 to that in 2002?
Offer a terse response. 1.06. What is the ratio of the Taxes (in constant 2015 US$) in Burkina Faso in 2001 to that in 2003?
Offer a very short reply. 0.63. What is the ratio of the Taxes (in constant 2015 US$) of New Zealand in 2001 to that in 2003?
Make the answer very short. 0.58. What is the ratio of the Taxes (in constant 2015 US$) in United Arab Emirates in 2001 to that in 2003?
Keep it short and to the point. 0.34. What is the ratio of the Taxes (in constant 2015 US$) in Zambia in 2001 to that in 2003?
Your answer should be compact. 0.95. What is the ratio of the Taxes (in constant 2015 US$) in Burkina Faso in 2001 to that in 2004?
Give a very brief answer. 0.47. What is the ratio of the Taxes (in constant 2015 US$) in New Zealand in 2001 to that in 2004?
Keep it short and to the point. 0.49. What is the ratio of the Taxes (in constant 2015 US$) in United Arab Emirates in 2001 to that in 2004?
Offer a very short reply. 0.3. What is the ratio of the Taxes (in constant 2015 US$) in Zambia in 2001 to that in 2004?
Make the answer very short. 0.8. What is the ratio of the Taxes (in constant 2015 US$) of Burkina Faso in 2001 to that in 2005?
Your response must be concise. 0.37. What is the ratio of the Taxes (in constant 2015 US$) of New Zealand in 2001 to that in 2005?
Your response must be concise. 0.44. What is the ratio of the Taxes (in constant 2015 US$) in United Arab Emirates in 2001 to that in 2005?
Ensure brevity in your answer.  0.23. What is the ratio of the Taxes (in constant 2015 US$) of Zambia in 2001 to that in 2005?
Provide a short and direct response. 0.61. What is the ratio of the Taxes (in constant 2015 US$) of Burkina Faso in 2001 to that in 2006?
Keep it short and to the point. 0.41. What is the ratio of the Taxes (in constant 2015 US$) of New Zealand in 2001 to that in 2006?
Keep it short and to the point. 0.43. What is the ratio of the Taxes (in constant 2015 US$) in United Arab Emirates in 2001 to that in 2006?
Your answer should be very brief. 0.19. What is the ratio of the Taxes (in constant 2015 US$) in Zambia in 2001 to that in 2006?
Give a very brief answer. 0.43. What is the ratio of the Taxes (in constant 2015 US$) of Burkina Faso in 2001 to that in 2007?
Your answer should be very brief. 0.34. What is the ratio of the Taxes (in constant 2015 US$) in New Zealand in 2001 to that in 2007?
Your answer should be very brief. 0.35. What is the ratio of the Taxes (in constant 2015 US$) in United Arab Emirates in 2001 to that in 2007?
Keep it short and to the point. 0.15. What is the ratio of the Taxes (in constant 2015 US$) in Zambia in 2001 to that in 2007?
Your answer should be compact. 0.41. What is the ratio of the Taxes (in constant 2015 US$) of Burkina Faso in 2002 to that in 2003?
Ensure brevity in your answer.  0.75. What is the ratio of the Taxes (in constant 2015 US$) in New Zealand in 2002 to that in 2003?
Your response must be concise. 0.75. What is the ratio of the Taxes (in constant 2015 US$) of United Arab Emirates in 2002 to that in 2003?
Your answer should be compact. 0.72. What is the ratio of the Taxes (in constant 2015 US$) of Zambia in 2002 to that in 2003?
Offer a terse response. 0.9. What is the ratio of the Taxes (in constant 2015 US$) in Burkina Faso in 2002 to that in 2004?
Make the answer very short. 0.57. What is the ratio of the Taxes (in constant 2015 US$) in New Zealand in 2002 to that in 2004?
Your response must be concise. 0.63. What is the ratio of the Taxes (in constant 2015 US$) of United Arab Emirates in 2002 to that in 2004?
Your answer should be very brief. 0.62. What is the ratio of the Taxes (in constant 2015 US$) of Zambia in 2002 to that in 2004?
Give a very brief answer. 0.75. What is the ratio of the Taxes (in constant 2015 US$) of Burkina Faso in 2002 to that in 2005?
Offer a terse response. 0.44. What is the ratio of the Taxes (in constant 2015 US$) in New Zealand in 2002 to that in 2005?
Provide a succinct answer. 0.57. What is the ratio of the Taxes (in constant 2015 US$) of United Arab Emirates in 2002 to that in 2005?
Your answer should be very brief. 0.48. What is the ratio of the Taxes (in constant 2015 US$) of Zambia in 2002 to that in 2005?
Give a very brief answer. 0.58. What is the ratio of the Taxes (in constant 2015 US$) in Burkina Faso in 2002 to that in 2006?
Make the answer very short. 0.49. What is the ratio of the Taxes (in constant 2015 US$) in New Zealand in 2002 to that in 2006?
Offer a terse response. 0.55. What is the ratio of the Taxes (in constant 2015 US$) of United Arab Emirates in 2002 to that in 2006?
Offer a very short reply. 0.39. What is the ratio of the Taxes (in constant 2015 US$) of Zambia in 2002 to that in 2006?
Offer a very short reply. 0.41. What is the ratio of the Taxes (in constant 2015 US$) of Burkina Faso in 2002 to that in 2007?
Keep it short and to the point. 0.41. What is the ratio of the Taxes (in constant 2015 US$) of New Zealand in 2002 to that in 2007?
Make the answer very short. 0.45. What is the ratio of the Taxes (in constant 2015 US$) in United Arab Emirates in 2002 to that in 2007?
Provide a succinct answer. 0.32. What is the ratio of the Taxes (in constant 2015 US$) of Zambia in 2002 to that in 2007?
Give a very brief answer. 0.39. What is the ratio of the Taxes (in constant 2015 US$) of Burkina Faso in 2003 to that in 2004?
Keep it short and to the point. 0.76. What is the ratio of the Taxes (in constant 2015 US$) in New Zealand in 2003 to that in 2004?
Ensure brevity in your answer.  0.84. What is the ratio of the Taxes (in constant 2015 US$) in United Arab Emirates in 2003 to that in 2004?
Provide a short and direct response. 0.86. What is the ratio of the Taxes (in constant 2015 US$) of Zambia in 2003 to that in 2004?
Offer a very short reply. 0.84. What is the ratio of the Taxes (in constant 2015 US$) in Burkina Faso in 2003 to that in 2005?
Offer a very short reply. 0.59. What is the ratio of the Taxes (in constant 2015 US$) of New Zealand in 2003 to that in 2005?
Give a very brief answer. 0.75. What is the ratio of the Taxes (in constant 2015 US$) of United Arab Emirates in 2003 to that in 2005?
Make the answer very short. 0.67. What is the ratio of the Taxes (in constant 2015 US$) of Zambia in 2003 to that in 2005?
Give a very brief answer. 0.64. What is the ratio of the Taxes (in constant 2015 US$) of Burkina Faso in 2003 to that in 2006?
Offer a terse response. 0.66. What is the ratio of the Taxes (in constant 2015 US$) in New Zealand in 2003 to that in 2006?
Offer a terse response. 0.73. What is the ratio of the Taxes (in constant 2015 US$) of United Arab Emirates in 2003 to that in 2006?
Provide a succinct answer. 0.54. What is the ratio of the Taxes (in constant 2015 US$) in Zambia in 2003 to that in 2006?
Your response must be concise. 0.46. What is the ratio of the Taxes (in constant 2015 US$) in Burkina Faso in 2003 to that in 2007?
Your answer should be compact. 0.54. What is the ratio of the Taxes (in constant 2015 US$) of New Zealand in 2003 to that in 2007?
Offer a terse response. 0.6. What is the ratio of the Taxes (in constant 2015 US$) in United Arab Emirates in 2003 to that in 2007?
Ensure brevity in your answer.  0.45. What is the ratio of the Taxes (in constant 2015 US$) of Zambia in 2003 to that in 2007?
Ensure brevity in your answer.  0.43. What is the ratio of the Taxes (in constant 2015 US$) of Burkina Faso in 2004 to that in 2005?
Give a very brief answer. 0.78. What is the ratio of the Taxes (in constant 2015 US$) in New Zealand in 2004 to that in 2005?
Your response must be concise. 0.9. What is the ratio of the Taxes (in constant 2015 US$) of United Arab Emirates in 2004 to that in 2005?
Your answer should be compact. 0.78. What is the ratio of the Taxes (in constant 2015 US$) of Zambia in 2004 to that in 2005?
Your answer should be compact. 0.77. What is the ratio of the Taxes (in constant 2015 US$) in Burkina Faso in 2004 to that in 2006?
Offer a terse response. 0.87. What is the ratio of the Taxes (in constant 2015 US$) of New Zealand in 2004 to that in 2006?
Your answer should be very brief. 0.87. What is the ratio of the Taxes (in constant 2015 US$) in United Arab Emirates in 2004 to that in 2006?
Ensure brevity in your answer.  0.63. What is the ratio of the Taxes (in constant 2015 US$) in Zambia in 2004 to that in 2006?
Give a very brief answer. 0.54. What is the ratio of the Taxes (in constant 2015 US$) of Burkina Faso in 2004 to that in 2007?
Ensure brevity in your answer.  0.72. What is the ratio of the Taxes (in constant 2015 US$) of New Zealand in 2004 to that in 2007?
Make the answer very short. 0.72. What is the ratio of the Taxes (in constant 2015 US$) in United Arab Emirates in 2004 to that in 2007?
Your response must be concise. 0.52. What is the ratio of the Taxes (in constant 2015 US$) of Zambia in 2004 to that in 2007?
Give a very brief answer. 0.51. What is the ratio of the Taxes (in constant 2015 US$) in Burkina Faso in 2005 to that in 2006?
Your answer should be very brief. 1.12. What is the ratio of the Taxes (in constant 2015 US$) in New Zealand in 2005 to that in 2006?
Your answer should be very brief. 0.97. What is the ratio of the Taxes (in constant 2015 US$) of United Arab Emirates in 2005 to that in 2006?
Your answer should be very brief. 0.81. What is the ratio of the Taxes (in constant 2015 US$) in Zambia in 2005 to that in 2006?
Provide a short and direct response. 0.71. What is the ratio of the Taxes (in constant 2015 US$) in Burkina Faso in 2005 to that in 2007?
Your answer should be compact. 0.92. What is the ratio of the Taxes (in constant 2015 US$) in New Zealand in 2005 to that in 2007?
Provide a short and direct response. 0.8. What is the ratio of the Taxes (in constant 2015 US$) of United Arab Emirates in 2005 to that in 2007?
Your answer should be very brief. 0.67. What is the ratio of the Taxes (in constant 2015 US$) of Zambia in 2005 to that in 2007?
Your answer should be very brief. 0.67. What is the ratio of the Taxes (in constant 2015 US$) of Burkina Faso in 2006 to that in 2007?
Your answer should be compact. 0.82. What is the ratio of the Taxes (in constant 2015 US$) of New Zealand in 2006 to that in 2007?
Provide a succinct answer. 0.83. What is the ratio of the Taxes (in constant 2015 US$) of United Arab Emirates in 2006 to that in 2007?
Provide a short and direct response. 0.82. What is the ratio of the Taxes (in constant 2015 US$) of Zambia in 2006 to that in 2007?
Keep it short and to the point. 0.94. What is the difference between the highest and the second highest Taxes (in constant 2015 US$) in Burkina Faso?
Ensure brevity in your answer.  4.30e+07. What is the difference between the highest and the second highest Taxes (in constant 2015 US$) of New Zealand?
Give a very brief answer. 1.82e+09. What is the difference between the highest and the second highest Taxes (in constant 2015 US$) of United Arab Emirates?
Give a very brief answer. 3.61e+08. What is the difference between the highest and the second highest Taxes (in constant 2015 US$) of Zambia?
Your answer should be very brief. 6.60e+07. What is the difference between the highest and the lowest Taxes (in constant 2015 US$) in Burkina Faso?
Make the answer very short. 3.73e+08. What is the difference between the highest and the lowest Taxes (in constant 2015 US$) in New Zealand?
Give a very brief answer. 6.76e+09. What is the difference between the highest and the lowest Taxes (in constant 2015 US$) in United Arab Emirates?
Ensure brevity in your answer.  1.74e+09. What is the difference between the highest and the lowest Taxes (in constant 2015 US$) in Zambia?
Make the answer very short. 7.36e+08. 